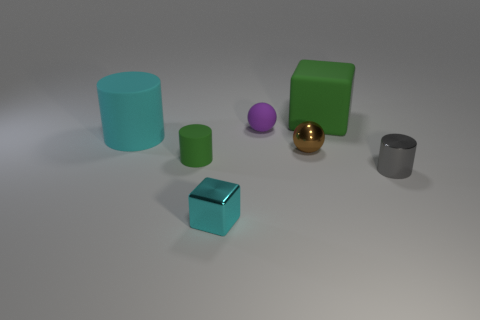There is a matte object to the right of the tiny purple rubber object; does it have the same color as the small cylinder that is to the left of the purple object?
Your answer should be very brief. Yes. Are there the same number of tiny blocks behind the gray cylinder and brown cylinders?
Offer a terse response. Yes. There is a small brown thing; how many tiny purple matte things are left of it?
Your answer should be compact. 1. The metal cylinder has what size?
Your response must be concise. Small. There is a big object that is the same material as the large cube; what is its color?
Offer a very short reply. Cyan. What number of green matte cylinders are the same size as the brown object?
Offer a very short reply. 1. Does the green thing left of the small purple matte thing have the same material as the gray cylinder?
Ensure brevity in your answer.  No. Is the number of metal cubes that are to the right of the tiny green cylinder less than the number of tiny metal cubes?
Provide a succinct answer. No. There is a big rubber thing that is right of the tiny cyan shiny cube; what is its shape?
Give a very brief answer. Cube. The cyan thing that is the same size as the metallic cylinder is what shape?
Provide a succinct answer. Cube. 